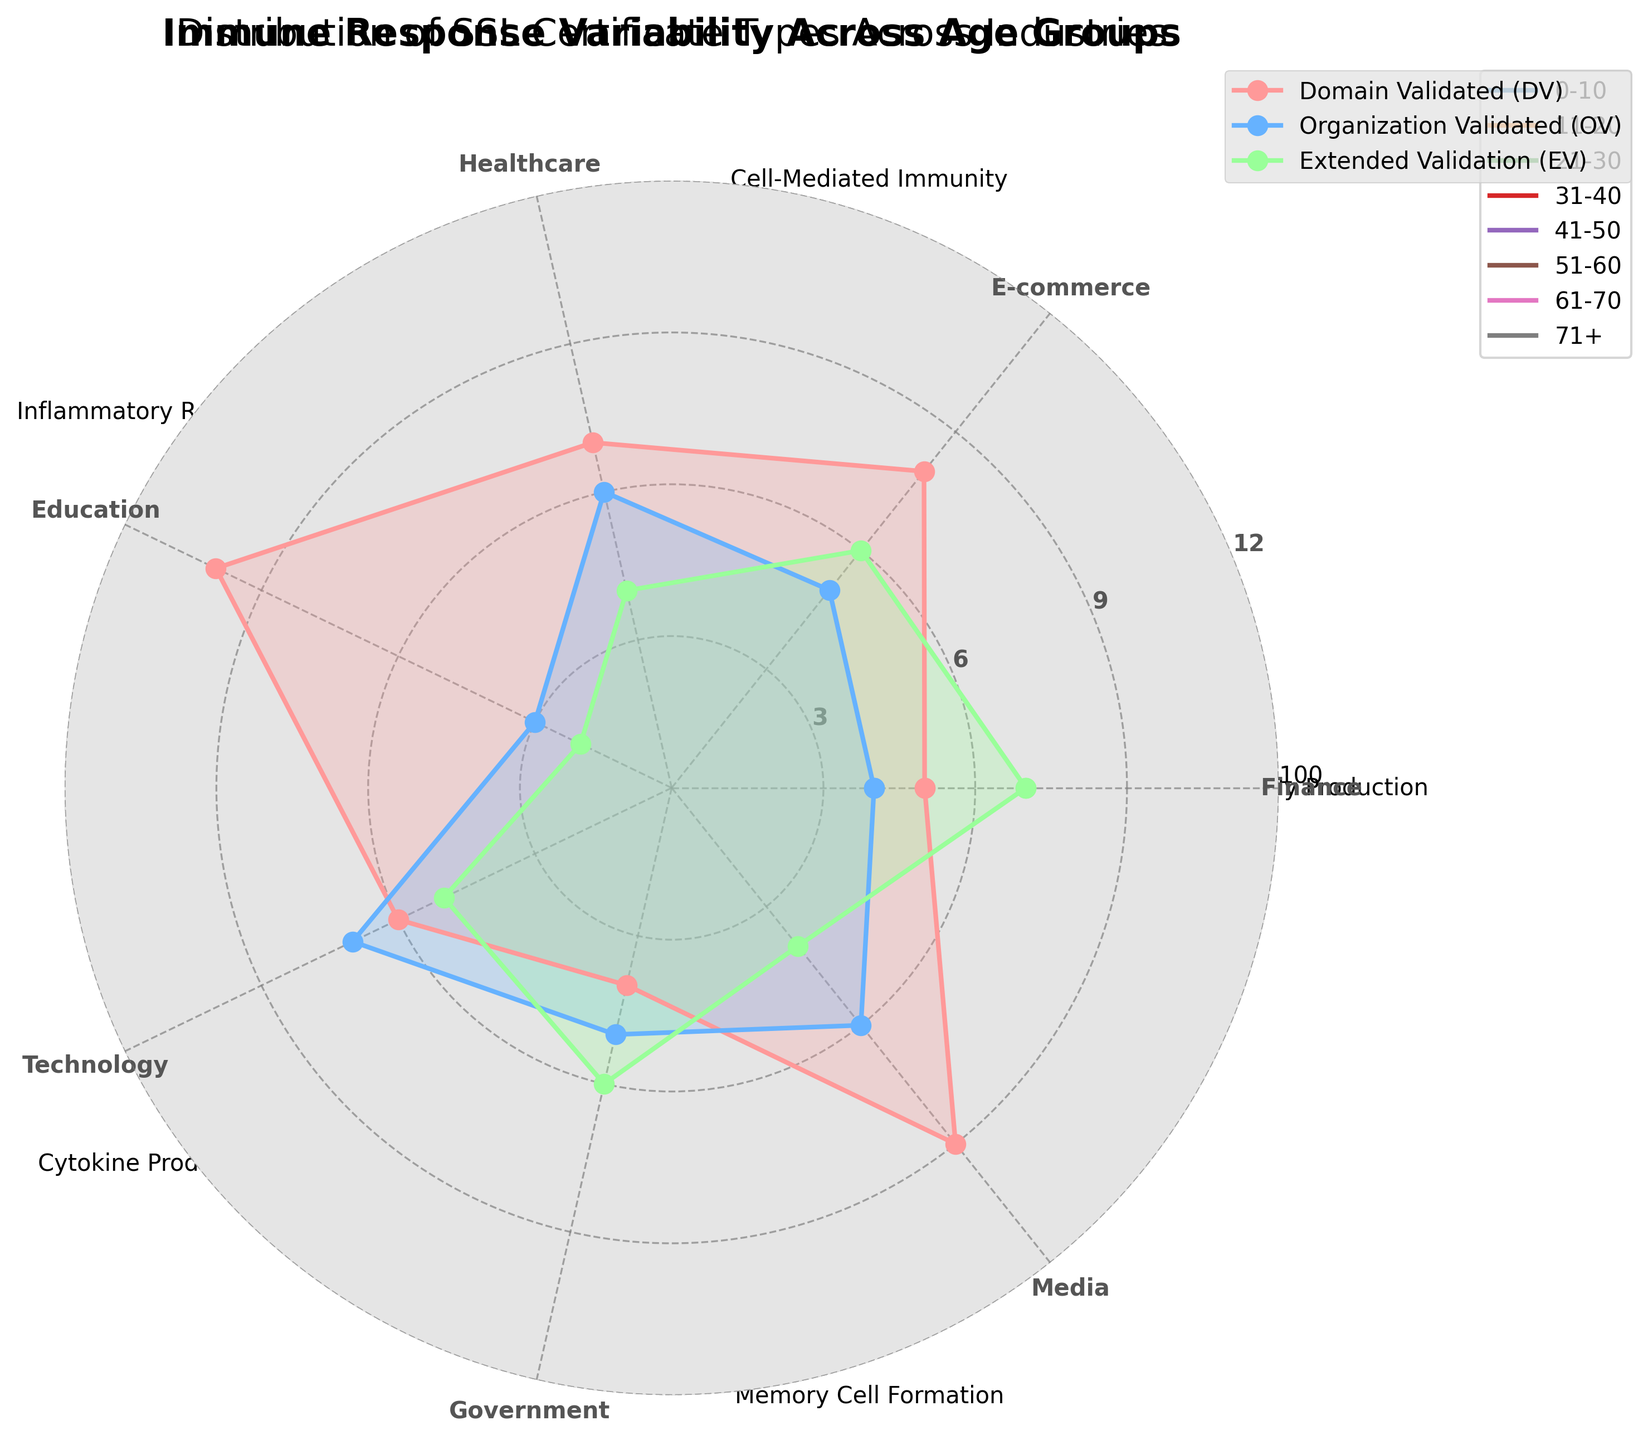What's the industry with the highest number of Extended Validation (EV) certificates? Look at the "Extended Validation (EV)" labels around the radar chart and compare the values. The Finance industry leads with the highest value at 7.
Answer: Finance What is the title of the radar chart? Check the top section of the radar chart for the title. The title is "Distribution of SSL Certificate Types Across Industries."
Answer: Distribution of SSL Certificate Types Across Industries How many industries have more than 5 Organization Validated (OV) certificates? Count the segments in the radar chart where the OV value is greater than 5. There are three industries (Healthcare, Technology, Media) that exceed 5 OV certificates.
Answer: 3 Which industry has the lowest number of Domain Validated (DV) certificates, and how many are there? Locate the DV values around the chart and find the smallest number. The Government industry has the lowest DV certificates at 4.
Answer: Government, 4 What's the sum of Domain Validated (DV) certificates in Technology and E-commerce industries? Add the DV values for Technology (6) and E-commerce (8). 6 + 8 equals 14.
Answer: 14 Which type of SSL certificate is highest for the Media industry? Check the values plotted for each SSL certificate type for Media and see which peaks highest. The highest type for Media is "Domain Validated (DV)" at 9.
Answer: Domain Validated (DV) Is the number of Extended Validation (EV) certificates for Healthcare higher than that for E-commerce? Compare the EV values for Healthcare (4) and E-commerce (6). Healthcare has fewer EV certificates than E-commerce.
Answer: No Which SSL certificate type has the most uniform distribution across all industries? Examine the smoothness or equality of the plotted lines for each SSL certificate type. The Organization Validated (OV) certificates have the most uniform distribution as their values are closer across industries.
Answer: Organization Validated (OV) What is the average number of Extended Validation (EV) certificates across all industries? Add up all the EV values (7+6+4+2+5+6+4) = 34, then divide by the number of industries (7). The result is 34 / 7 ≈ 4.857.
Answer: 4.857 Which industry has a significantly higher Domain Validated (DV) count than all other types of certificates? Compare bars within each sector around the radar chart. The Education industry has significantly higher DV (10) than its OV (3) and EV (2) values.
Answer: Education 